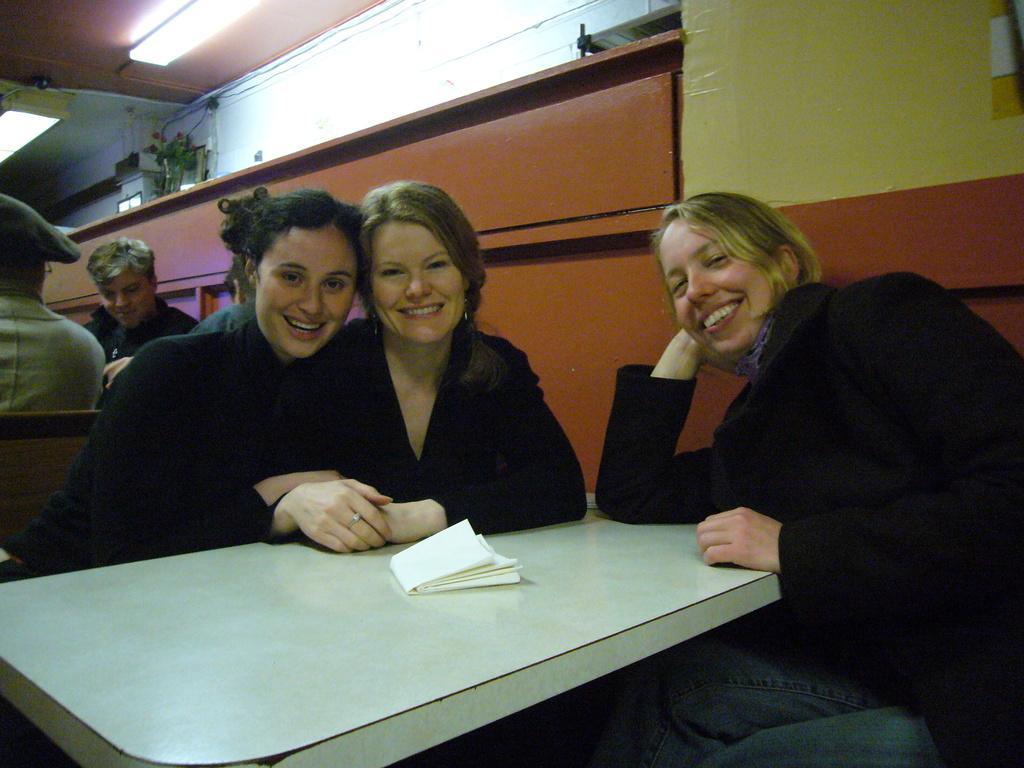In one or two sentences, can you explain what this image depicts? In this image I see 3 women and all of them are sitting, I also see that they are smiling, in front there is a table and a kerchief on it. In the background I see 2 men, wall and the light. 